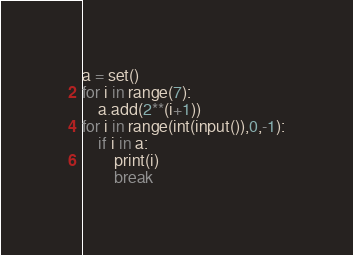Convert code to text. <code><loc_0><loc_0><loc_500><loc_500><_Python_>a = set()
for i in range(7):
    a.add(2**(i+1))
for i in range(int(input()),0,-1):
    if i in a:
        print(i)
        break</code> 